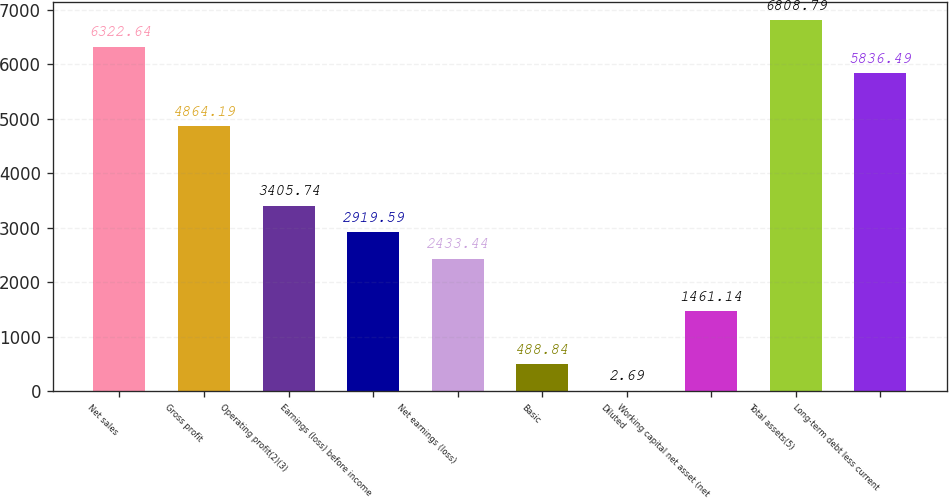<chart> <loc_0><loc_0><loc_500><loc_500><bar_chart><fcel>Net sales<fcel>Gross profit<fcel>Operating profit(2)(3)<fcel>Earnings (loss) before income<fcel>Net earnings (loss)<fcel>Basic<fcel>Diluted<fcel>Working capital net asset (net<fcel>Total assets(5)<fcel>Long-term debt less current<nl><fcel>6322.64<fcel>4864.19<fcel>3405.74<fcel>2919.59<fcel>2433.44<fcel>488.84<fcel>2.69<fcel>1461.14<fcel>6808.79<fcel>5836.49<nl></chart> 